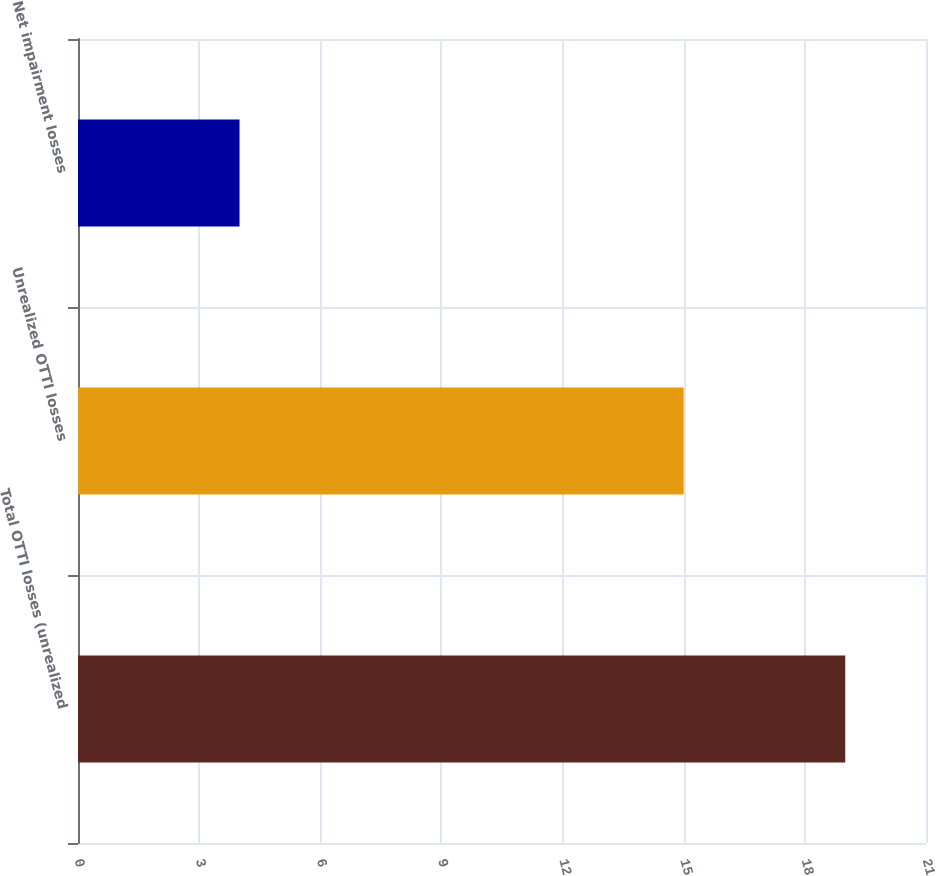<chart> <loc_0><loc_0><loc_500><loc_500><bar_chart><fcel>Total OTTI losses (unrealized<fcel>Unrealized OTTI losses<fcel>Net impairment losses<nl><fcel>19<fcel>15<fcel>4<nl></chart> 